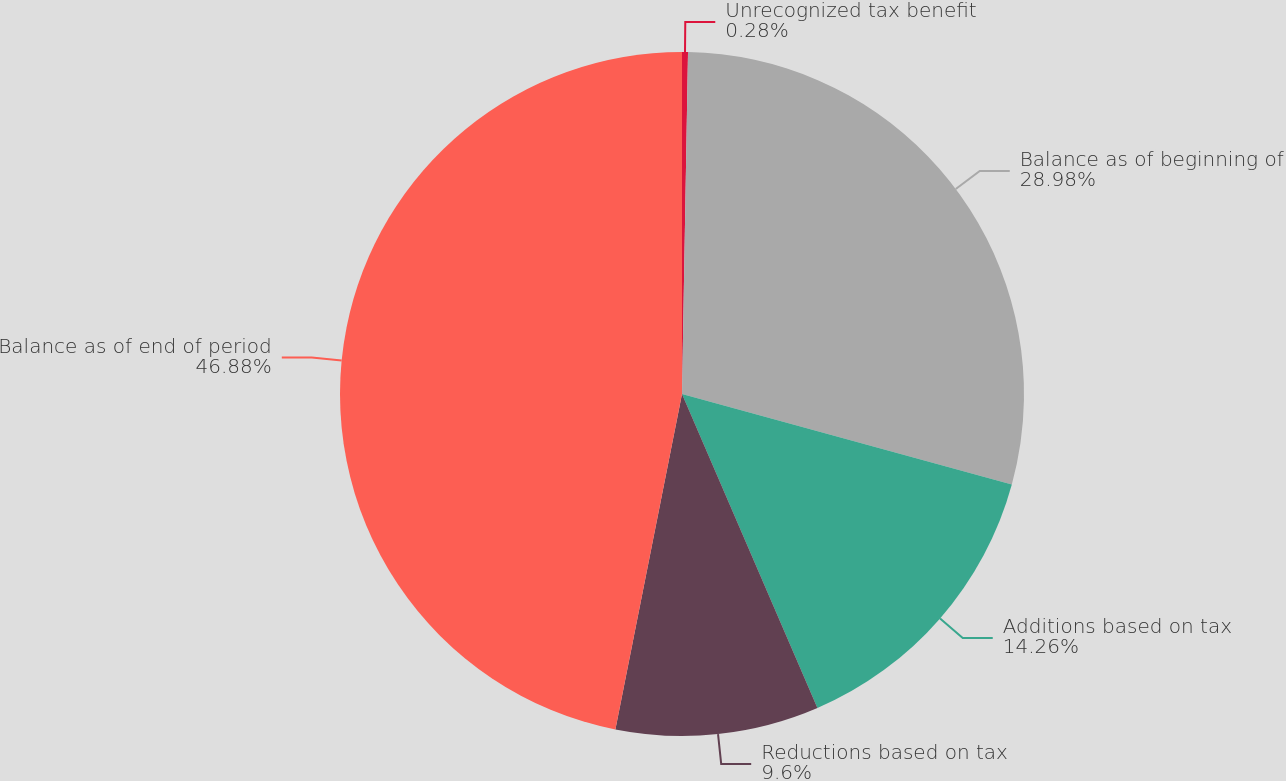Convert chart. <chart><loc_0><loc_0><loc_500><loc_500><pie_chart><fcel>Unrecognized tax benefit<fcel>Balance as of beginning of<fcel>Additions based on tax<fcel>Reductions based on tax<fcel>Balance as of end of period<nl><fcel>0.28%<fcel>28.98%<fcel>14.26%<fcel>9.6%<fcel>46.88%<nl></chart> 